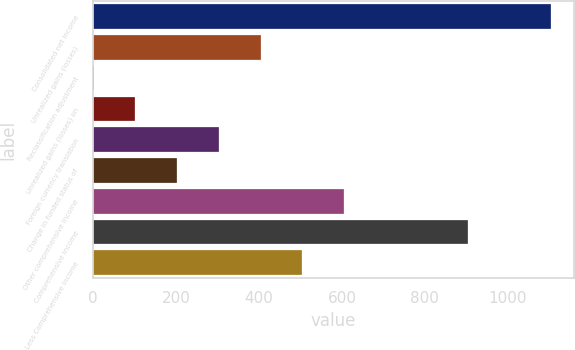Convert chart. <chart><loc_0><loc_0><loc_500><loc_500><bar_chart><fcel>Consolidated net income<fcel>Unrealized gains (losses)<fcel>Reclassification adjustment<fcel>Unrealized gains (losses) on<fcel>Foreign currency translation<fcel>Change in funded status of<fcel>Other comprehensive income<fcel>Comprehensive income<fcel>Less Comprehensive income<nl><fcel>1104.6<fcel>404.2<fcel>1<fcel>101.8<fcel>303.4<fcel>202.6<fcel>605.8<fcel>903<fcel>505<nl></chart> 